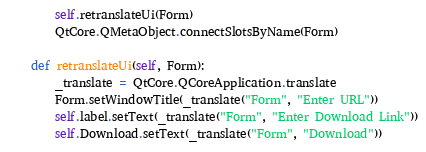<code> <loc_0><loc_0><loc_500><loc_500><_Python_>
        self.retranslateUi(Form)
        QtCore.QMetaObject.connectSlotsByName(Form)

    def retranslateUi(self, Form):
        _translate = QtCore.QCoreApplication.translate
        Form.setWindowTitle(_translate("Form", "Enter URL"))
        self.label.setText(_translate("Form", "Enter Download Link"))
        self.Download.setText(_translate("Form", "Download"))
</code> 